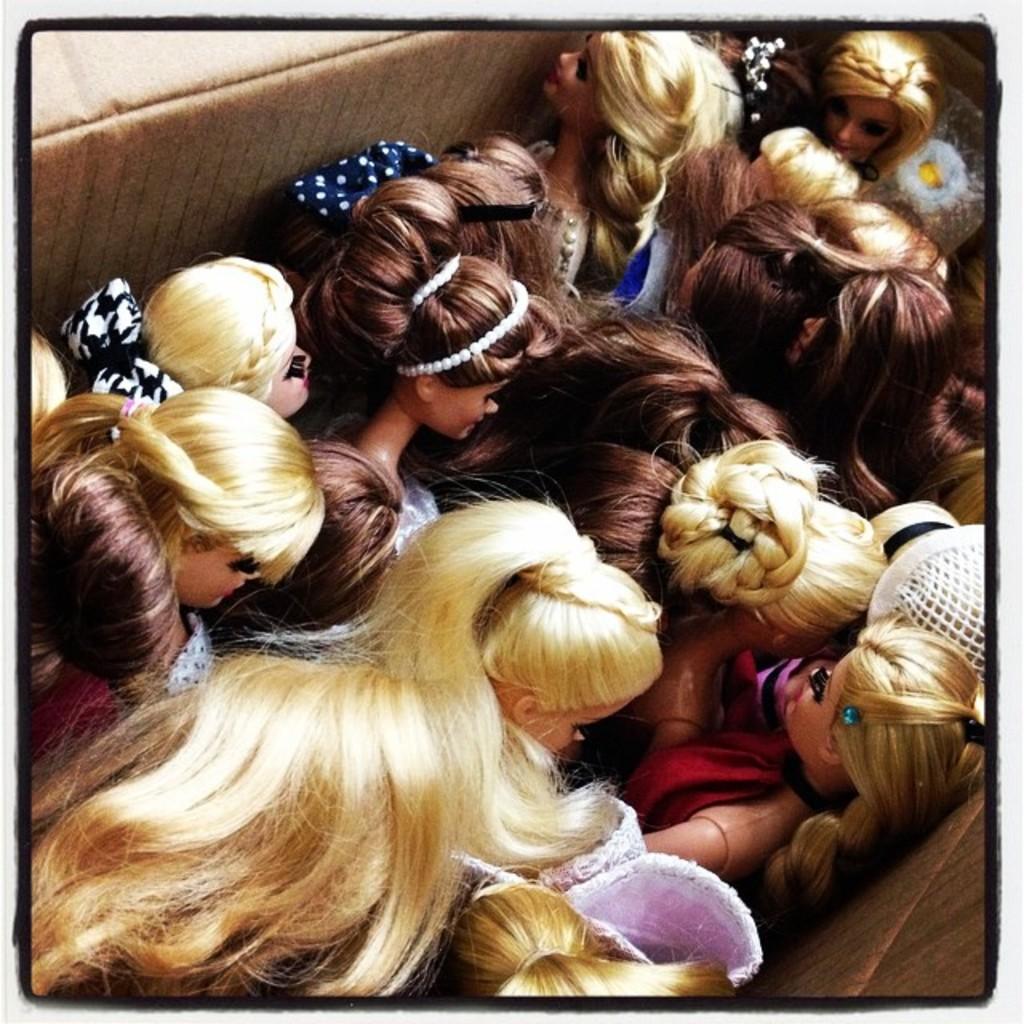Describe this image in one or two sentences. In the image we can see there are barbie dolls kept in the box and the barbie dolls are wearing different types of hairstyle. 